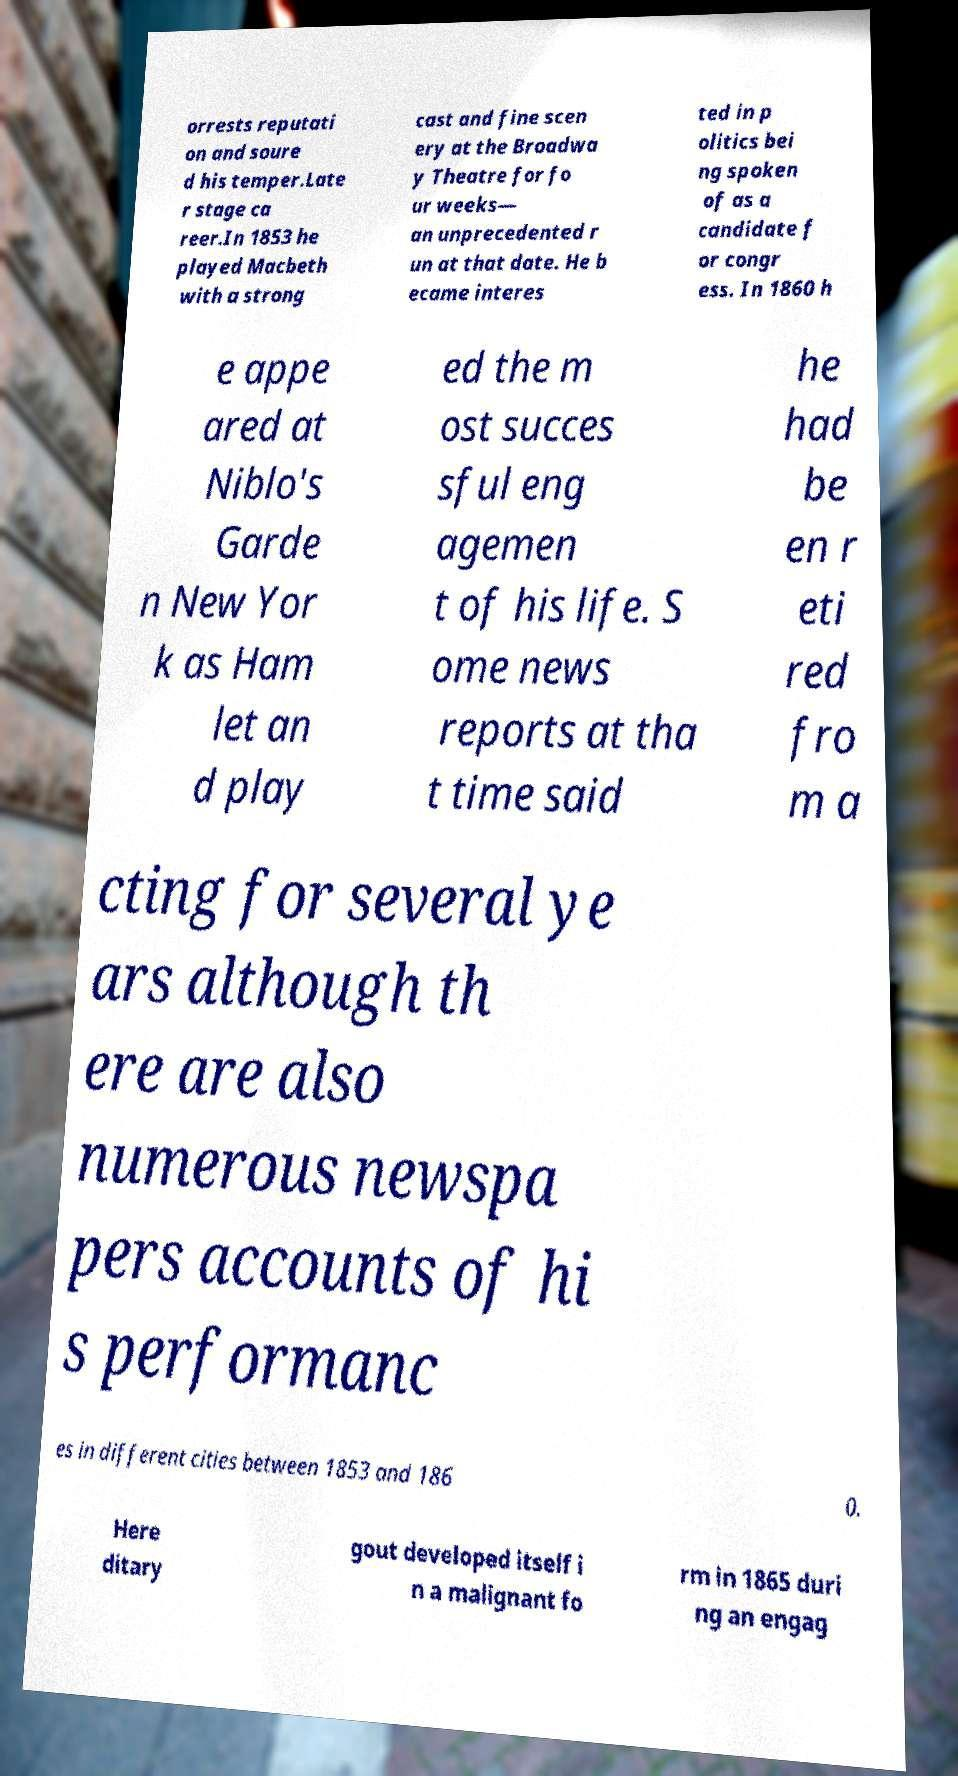Can you read and provide the text displayed in the image?This photo seems to have some interesting text. Can you extract and type it out for me? orrests reputati on and soure d his temper.Late r stage ca reer.In 1853 he played Macbeth with a strong cast and fine scen ery at the Broadwa y Theatre for fo ur weeks— an unprecedented r un at that date. He b ecame interes ted in p olitics bei ng spoken of as a candidate f or congr ess. In 1860 h e appe ared at Niblo's Garde n New Yor k as Ham let an d play ed the m ost succes sful eng agemen t of his life. S ome news reports at tha t time said he had be en r eti red fro m a cting for several ye ars although th ere are also numerous newspa pers accounts of hi s performanc es in different cities between 1853 and 186 0. Here ditary gout developed itself i n a malignant fo rm in 1865 duri ng an engag 